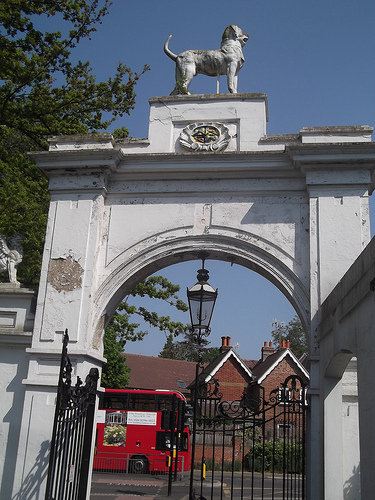<image>
Can you confirm if the missing patch is to the left of the window? Yes. From this viewpoint, the missing patch is positioned to the left side relative to the window. 